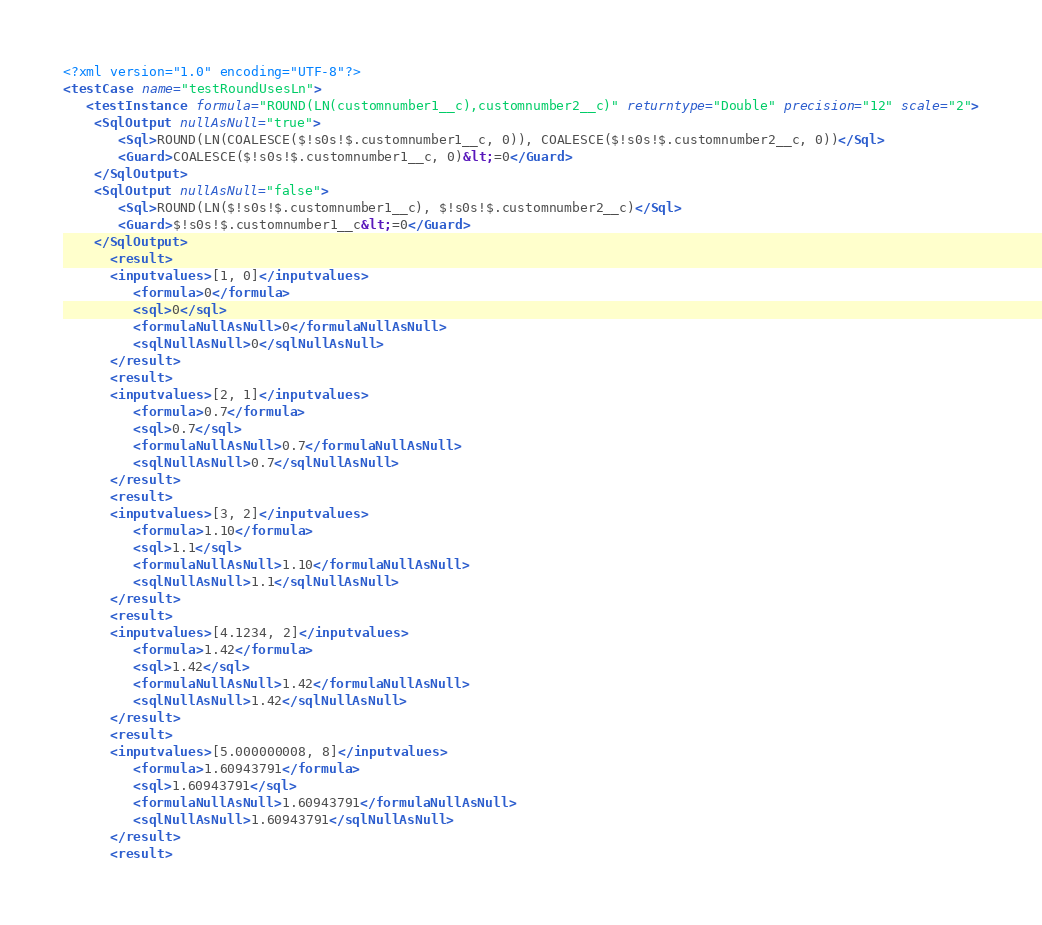<code> <loc_0><loc_0><loc_500><loc_500><_XML_><?xml version="1.0" encoding="UTF-8"?>
<testCase name="testRoundUsesLn">
   <testInstance formula="ROUND(LN(customnumber1__c),customnumber2__c)" returntype="Double" precision="12" scale="2">
    <SqlOutput nullAsNull="true">
       <Sql>ROUND(LN(COALESCE($!s0s!$.customnumber1__c, 0)), COALESCE($!s0s!$.customnumber2__c, 0))</Sql>
       <Guard>COALESCE($!s0s!$.customnumber1__c, 0)&lt;=0</Guard>
    </SqlOutput>
    <SqlOutput nullAsNull="false">
       <Sql>ROUND(LN($!s0s!$.customnumber1__c), $!s0s!$.customnumber2__c)</Sql>
       <Guard>$!s0s!$.customnumber1__c&lt;=0</Guard>
    </SqlOutput>
      <result>
      <inputvalues>[1, 0]</inputvalues>
         <formula>0</formula>
         <sql>0</sql>
         <formulaNullAsNull>0</formulaNullAsNull>
         <sqlNullAsNull>0</sqlNullAsNull>
      </result>
      <result>
      <inputvalues>[2, 1]</inputvalues>
         <formula>0.7</formula>
         <sql>0.7</sql>
         <formulaNullAsNull>0.7</formulaNullAsNull>
         <sqlNullAsNull>0.7</sqlNullAsNull>
      </result>
      <result>
      <inputvalues>[3, 2]</inputvalues>
         <formula>1.10</formula>
         <sql>1.1</sql>
         <formulaNullAsNull>1.10</formulaNullAsNull>
         <sqlNullAsNull>1.1</sqlNullAsNull>
      </result>
      <result>
      <inputvalues>[4.1234, 2]</inputvalues>
         <formula>1.42</formula>
         <sql>1.42</sql>
         <formulaNullAsNull>1.42</formulaNullAsNull>
         <sqlNullAsNull>1.42</sqlNullAsNull>
      </result>
      <result>
      <inputvalues>[5.000000008, 8]</inputvalues>
         <formula>1.60943791</formula>
         <sql>1.60943791</sql>
         <formulaNullAsNull>1.60943791</formulaNullAsNull>
         <sqlNullAsNull>1.60943791</sqlNullAsNull>
      </result>
      <result></code> 